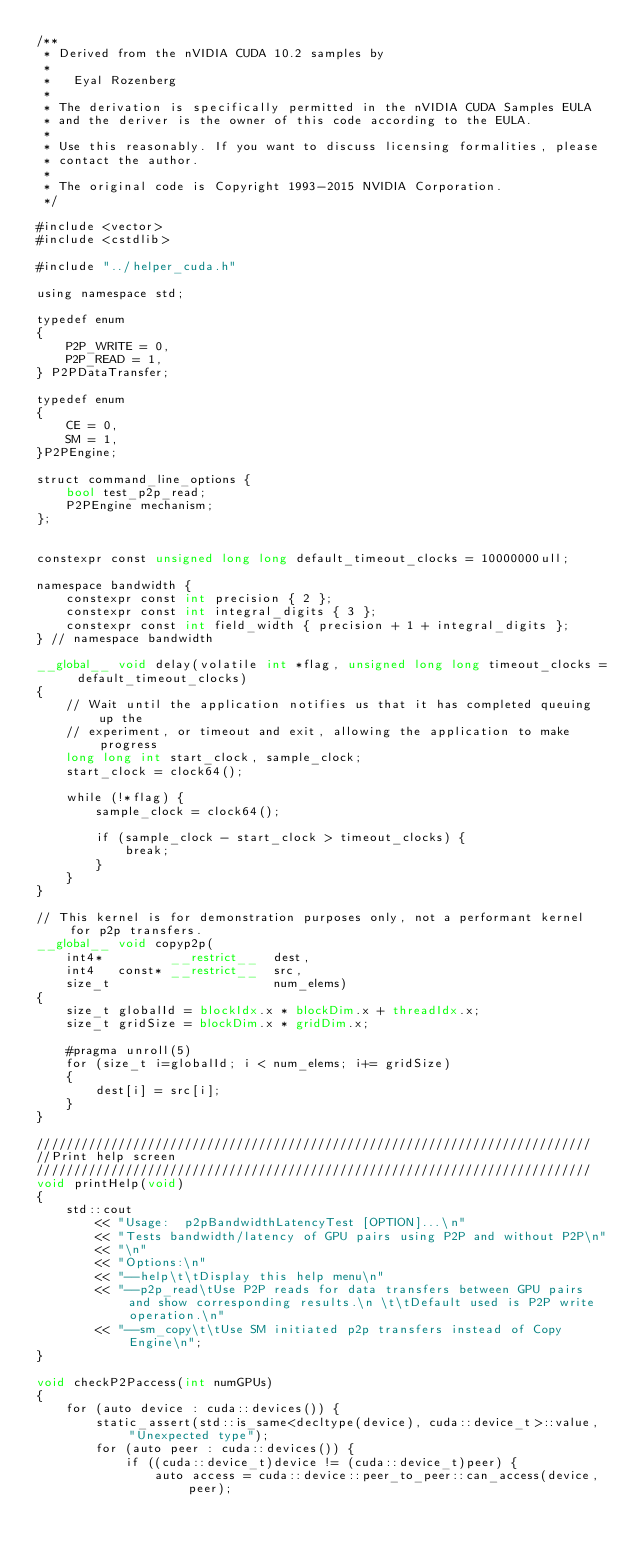<code> <loc_0><loc_0><loc_500><loc_500><_Cuda_>/**
 * Derived from the nVIDIA CUDA 10.2 samples by
 *
 *   Eyal Rozenberg
 *
 * The derivation is specifically permitted in the nVIDIA CUDA Samples EULA
 * and the deriver is the owner of this code according to the EULA.
 *
 * Use this reasonably. If you want to discuss licensing formalities, please
 * contact the author.
 *
 * The original code is Copyright 1993-2015 NVIDIA Corporation.
 */

#include <vector>
#include <cstdlib>

#include "../helper_cuda.h"

using namespace std;

typedef enum
{
    P2P_WRITE = 0,
    P2P_READ = 1,
} P2PDataTransfer;

typedef enum
{
    CE = 0, 
    SM = 1,
}P2PEngine;

struct command_line_options {
    bool test_p2p_read;
    P2PEngine mechanism;
};


constexpr const unsigned long long default_timeout_clocks = 10000000ull;

namespace bandwidth {
	constexpr const int precision { 2 };
	constexpr const int integral_digits { 3 };
	constexpr const int field_width { precision + 1 + integral_digits };
} // namespace bandwidth

__global__ void delay(volatile int *flag, unsigned long long timeout_clocks = default_timeout_clocks)
{
    // Wait until the application notifies us that it has completed queuing up the
    // experiment, or timeout and exit, allowing the application to make progress
    long long int start_clock, sample_clock;
    start_clock = clock64();

    while (!*flag) {
        sample_clock = clock64();

        if (sample_clock - start_clock > timeout_clocks) {
            break;
        }
    }
}

// This kernel is for demonstration purposes only, not a performant kernel for p2p transfers.
__global__ void copyp2p(
    int4*         __restrict__  dest,
    int4   const* __restrict__  src,
    size_t                      num_elems)
{
    size_t globalId = blockIdx.x * blockDim.x + threadIdx.x;
    size_t gridSize = blockDim.x * gridDim.x;

    #pragma unroll(5)
    for (size_t i=globalId; i < num_elems; i+= gridSize)
    {
        dest[i] = src[i];
    }
}

///////////////////////////////////////////////////////////////////////////
//Print help screen
///////////////////////////////////////////////////////////////////////////
void printHelp(void)
{
    std::cout
        << "Usage:  p2pBandwidthLatencyTest [OPTION]...\n"
        << "Tests bandwidth/latency of GPU pairs using P2P and without P2P\n"
        << "\n"
        << "Options:\n"
        << "--help\t\tDisplay this help menu\n"
        << "--p2p_read\tUse P2P reads for data transfers between GPU pairs and show corresponding results.\n \t\tDefault used is P2P write operation.\n"
        << "--sm_copy\t\tUse SM initiated p2p transfers instead of Copy Engine\n";
}

void checkP2Paccess(int numGPUs)
{
    for (auto device : cuda::devices()) {
    	static_assert(std::is_same<decltype(device), cuda::device_t>::value, "Unexpected type");
        for (auto peer : cuda::devices()) {
            if ((cuda::device_t)device != (cuda::device_t)peer) {
                auto access = cuda::device::peer_to_peer::can_access(device, peer);</code> 